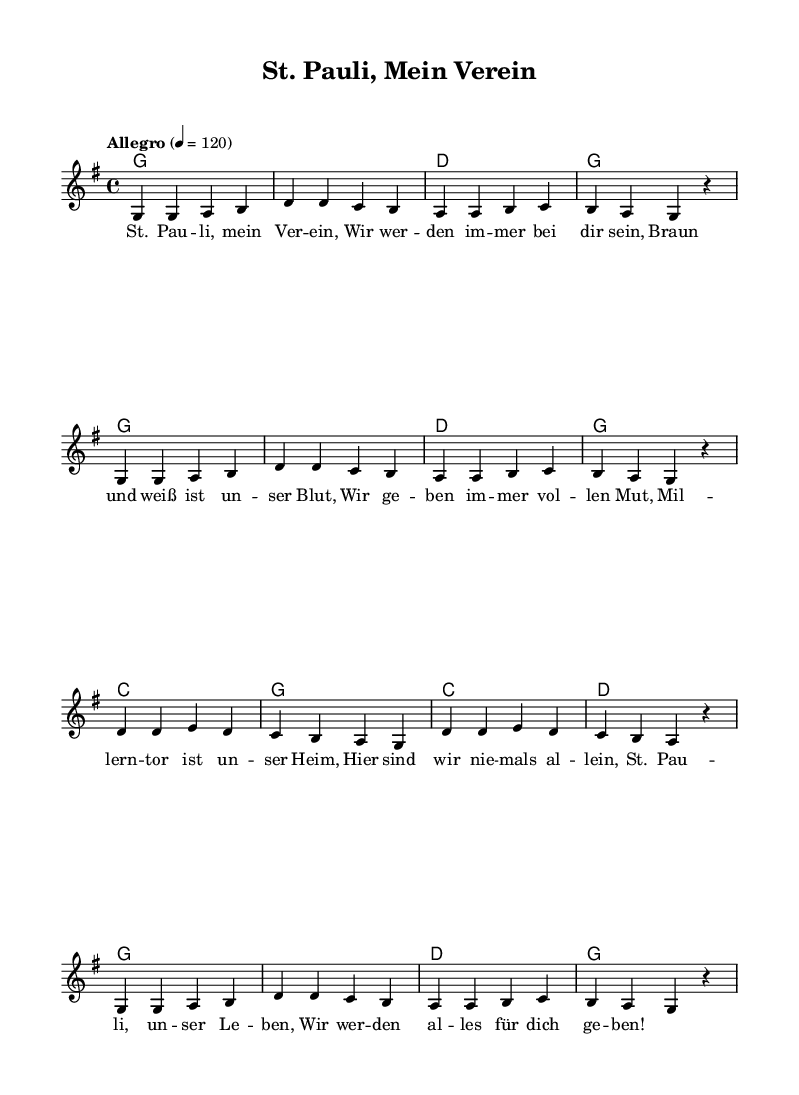What is the key signature of this music? The key signature is G major, which has one sharp (F#). This can be determined by looking at the key signature notation at the beginning of the staff in the music sheet.
Answer: G major What is the time signature of this music? The time signature is 4/4. This is visible at the beginning of the piece where it shows "4/4", indicating each measure has four beats and the quarter note receives one beat.
Answer: 4/4 What is the tempo marking in this music? The tempo marking is "Allegro", indicating a fast tempo. This is shown above the staff at the beginning of the score where it indicates the mood and speed of the music.
Answer: Allegro How many measures are in the melody? There are 8 measures in the melody. This is determined by counting each distinct grouping of notes separated by vertical lines on the staff.
Answer: 8 Which chords are used in the first section? The chords used are G and D. This can be observed in the chord mode section, where it starts with G and D for the first few measures indicating the predominant harmony in that section.
Answer: G, D What is the primary lyrical theme of the song? The primary lyrical theme is about loyalty to St. Pauli. By reading through the lyrics, it becomes clear that they express devotion and support towards the football club.
Answer: Loyalty to St. Pauli How many different chords are played in total throughout the piece? There are 4 different chords played in total. This is determined by examining the chord progression, which lists the unique chords used (G, D, C) throughout the piece.
Answer: 4 